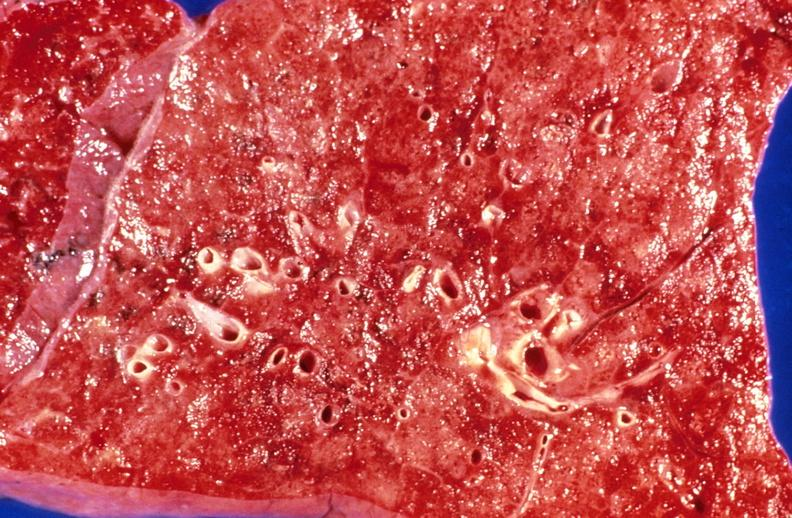s morphology present?
Answer the question using a single word or phrase. No 